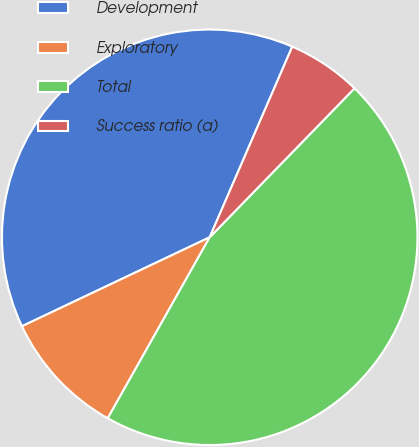<chart> <loc_0><loc_0><loc_500><loc_500><pie_chart><fcel>Development<fcel>Exploratory<fcel>Total<fcel>Success ratio (a)<nl><fcel>38.55%<fcel>9.79%<fcel>45.89%<fcel>5.77%<nl></chart> 